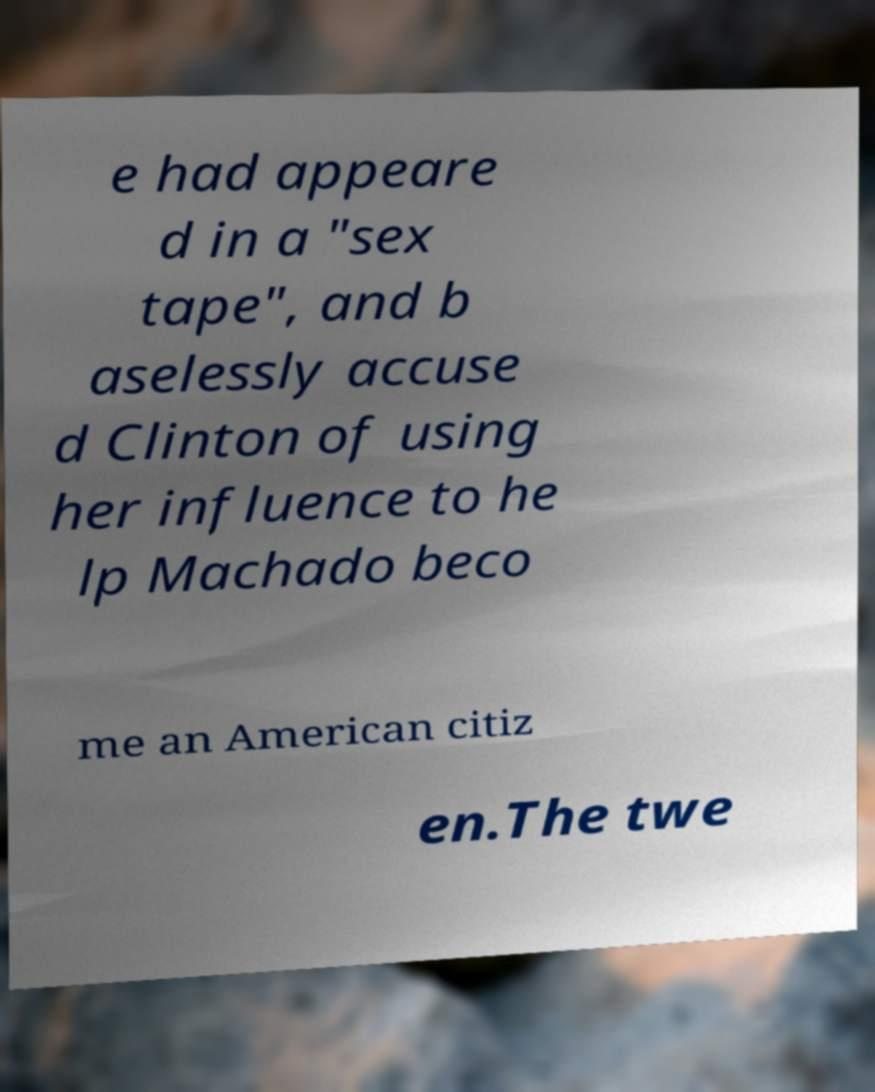What messages or text are displayed in this image? I need them in a readable, typed format. e had appeare d in a "sex tape", and b aselessly accuse d Clinton of using her influence to he lp Machado beco me an American citiz en.The twe 